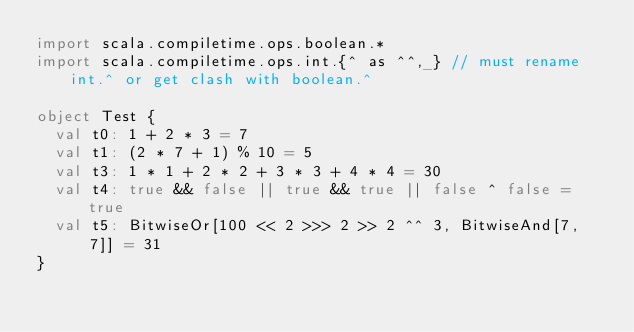<code> <loc_0><loc_0><loc_500><loc_500><_Scala_>import scala.compiletime.ops.boolean.*
import scala.compiletime.ops.int.{^ as ^^,_} // must rename int.^ or get clash with boolean.^

object Test {
  val t0: 1 + 2 * 3 = 7
  val t1: (2 * 7 + 1) % 10 = 5
  val t3: 1 * 1 + 2 * 2 + 3 * 3 + 4 * 4 = 30
  val t4: true && false || true && true || false ^ false = true
  val t5: BitwiseOr[100 << 2 >>> 2 >> 2 ^^ 3, BitwiseAnd[7, 7]] = 31
}
</code> 